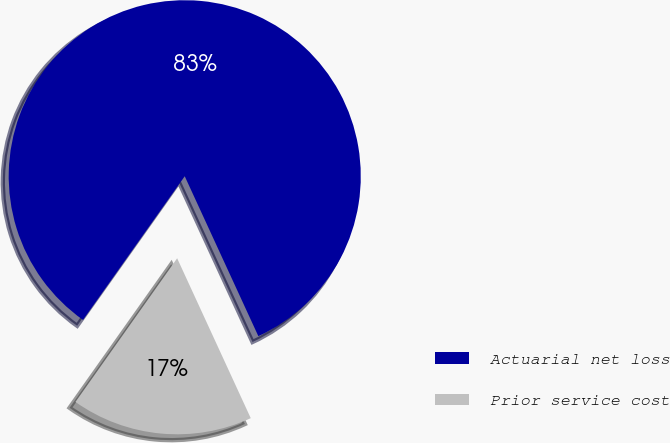Convert chart. <chart><loc_0><loc_0><loc_500><loc_500><pie_chart><fcel>Actuarial net loss<fcel>Prior service cost<nl><fcel>83.33%<fcel>16.67%<nl></chart> 